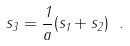<formula> <loc_0><loc_0><loc_500><loc_500>s _ { 3 } = \frac { 1 } { a } ( { s _ { 1 } + s _ { 2 } } ) \ .</formula> 